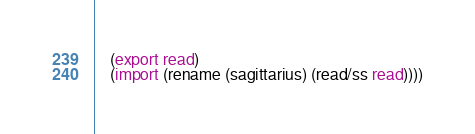Convert code to text. <code><loc_0><loc_0><loc_500><loc_500><_Scheme_>    (export read)
    (import (rename (sagittarius) (read/ss read))))</code> 